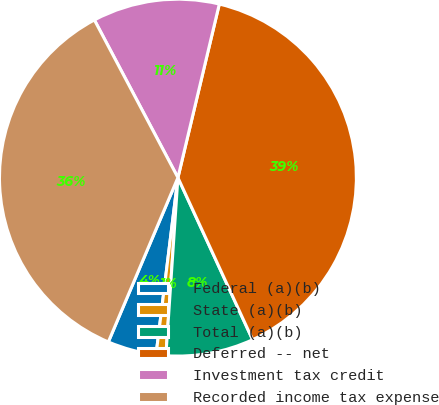Convert chart to OTSL. <chart><loc_0><loc_0><loc_500><loc_500><pie_chart><fcel>Federal (a)(b)<fcel>State (a)(b)<fcel>Total (a)(b)<fcel>Deferred -- net<fcel>Investment tax credit<fcel>Recorded income tax expense<nl><fcel>4.42%<fcel>0.88%<fcel>7.95%<fcel>39.4%<fcel>11.48%<fcel>35.87%<nl></chart> 